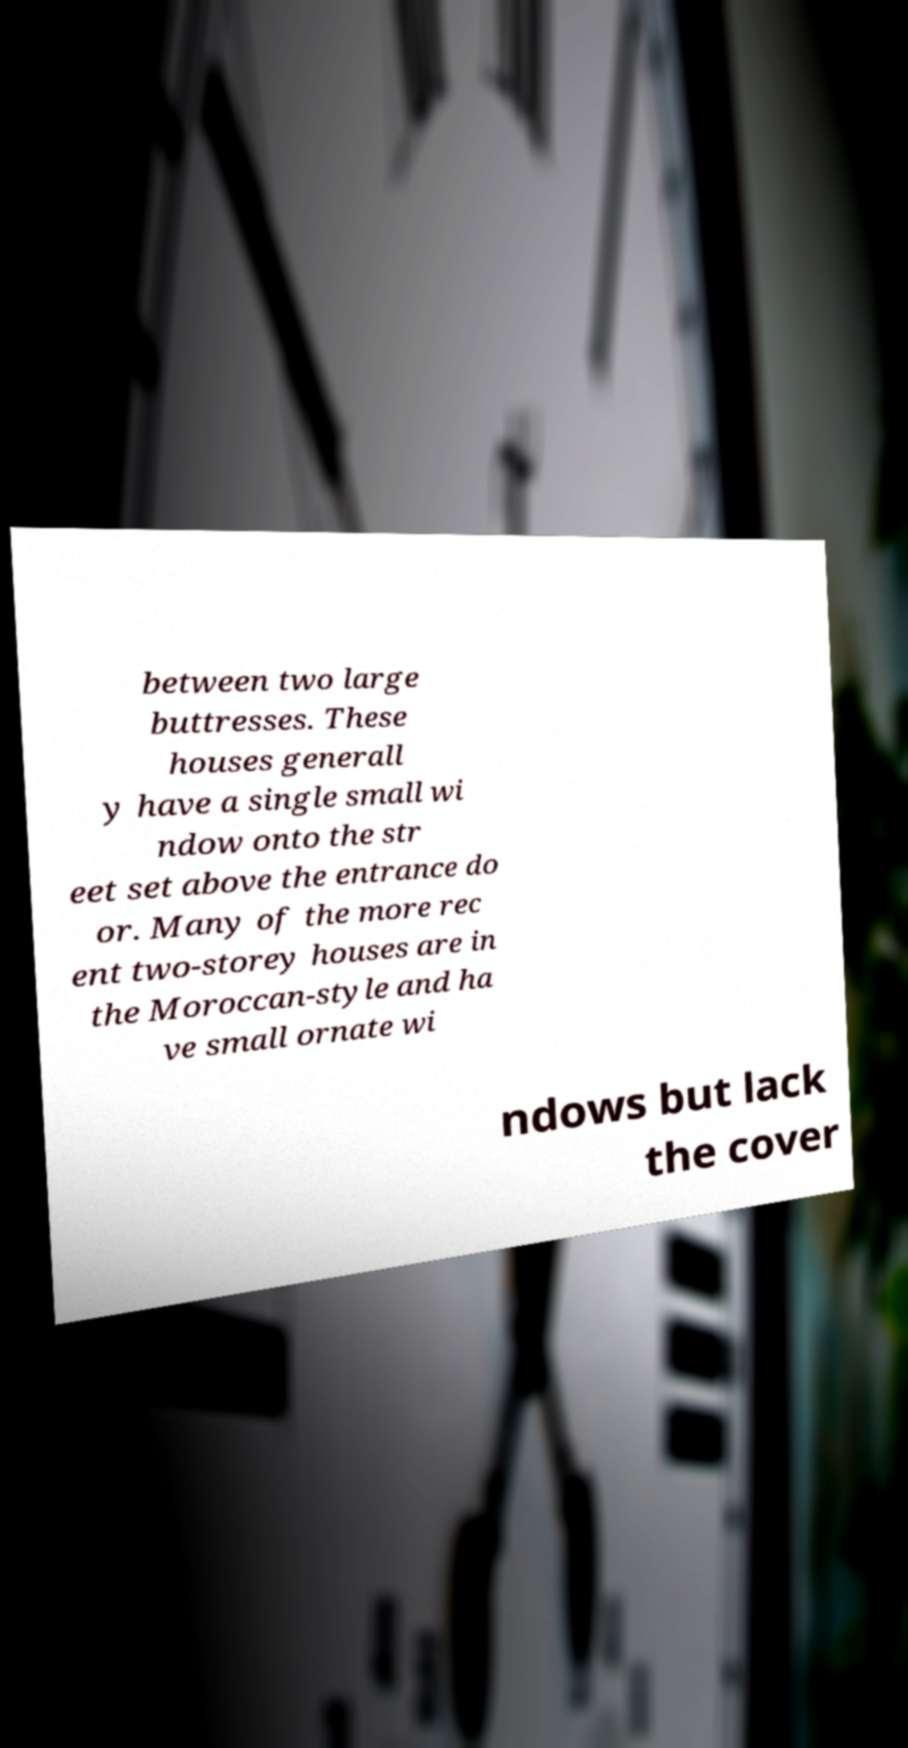For documentation purposes, I need the text within this image transcribed. Could you provide that? between two large buttresses. These houses generall y have a single small wi ndow onto the str eet set above the entrance do or. Many of the more rec ent two-storey houses are in the Moroccan-style and ha ve small ornate wi ndows but lack the cover 